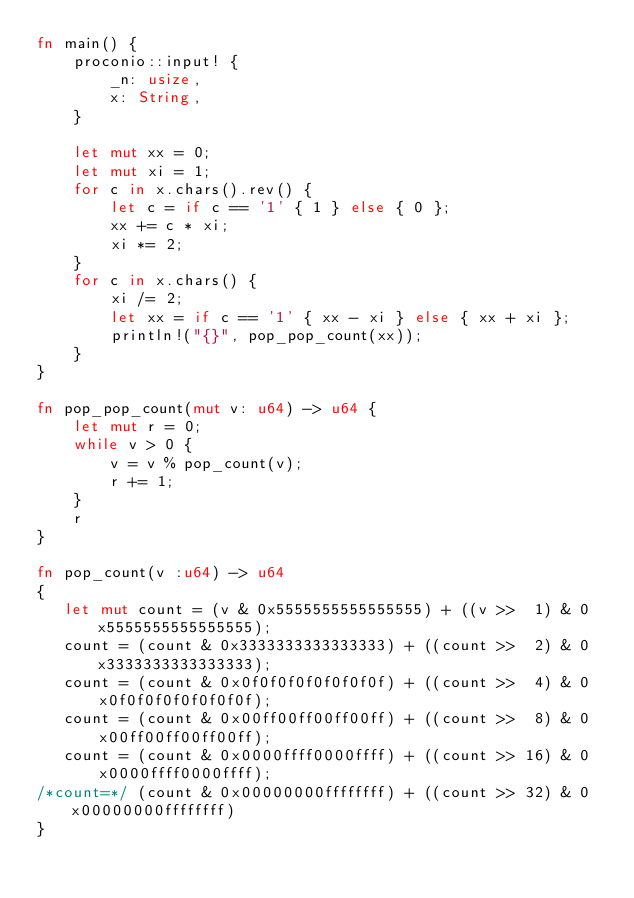<code> <loc_0><loc_0><loc_500><loc_500><_Rust_>fn main() {
    proconio::input! {
        _n: usize,
        x: String,
    }

    let mut xx = 0;
    let mut xi = 1;
    for c in x.chars().rev() {
        let c = if c == '1' { 1 } else { 0 };
        xx += c * xi;
        xi *= 2;
    }
    for c in x.chars() {
        xi /= 2;
        let xx = if c == '1' { xx - xi } else { xx + xi };
        println!("{}", pop_pop_count(xx));
    }
}

fn pop_pop_count(mut v: u64) -> u64 {
    let mut r = 0;
    while v > 0 {
        v = v % pop_count(v);
        r += 1;
    }
    r
}

fn pop_count(v :u64) -> u64
{
   let mut count = (v & 0x5555555555555555) + ((v >>  1) & 0x5555555555555555);
   count = (count & 0x3333333333333333) + ((count >>  2) & 0x3333333333333333);
   count = (count & 0x0f0f0f0f0f0f0f0f) + ((count >>  4) & 0x0f0f0f0f0f0f0f0f);
   count = (count & 0x00ff00ff00ff00ff) + ((count >>  8) & 0x00ff00ff00ff00ff);
   count = (count & 0x0000ffff0000ffff) + ((count >> 16) & 0x0000ffff0000ffff);
/*count=*/ (count & 0x00000000ffffffff) + ((count >> 32) & 0x00000000ffffffff)
}
</code> 